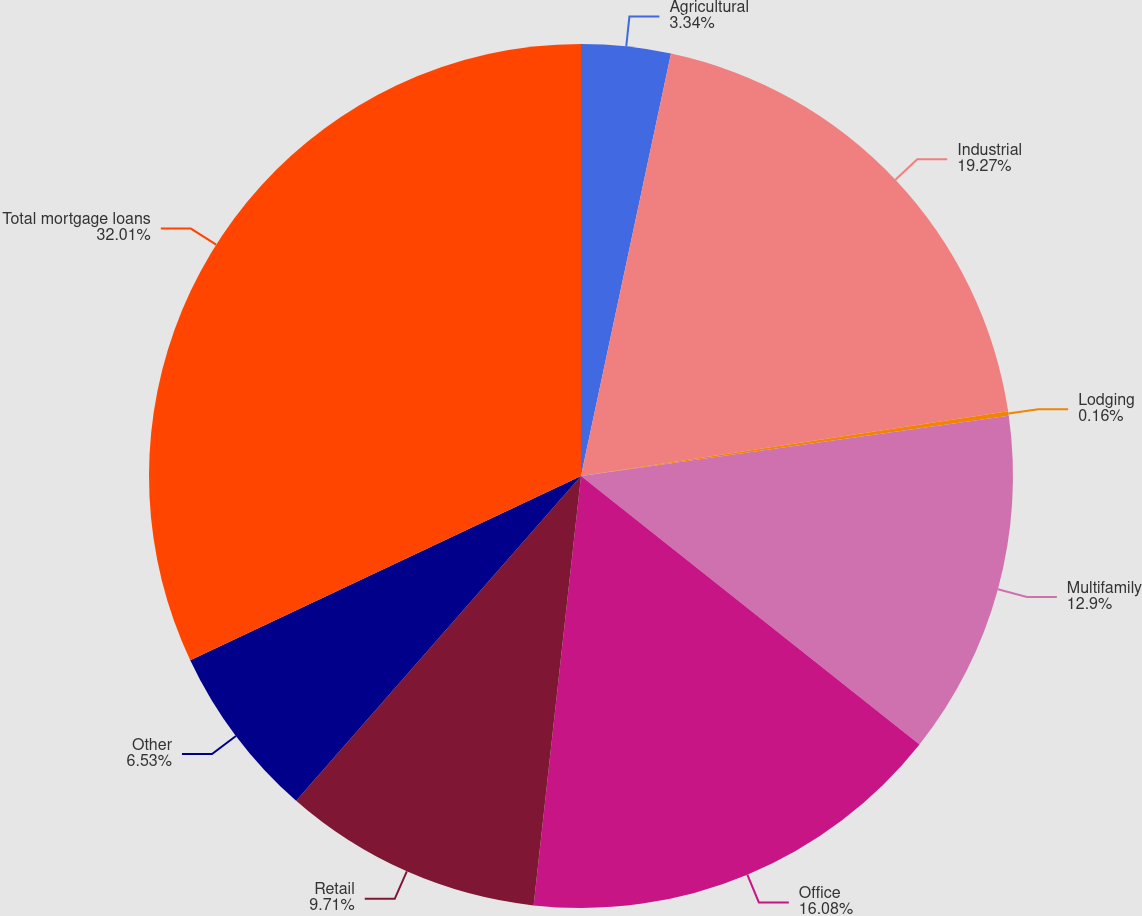Convert chart to OTSL. <chart><loc_0><loc_0><loc_500><loc_500><pie_chart><fcel>Agricultural<fcel>Industrial<fcel>Lodging<fcel>Multifamily<fcel>Office<fcel>Retail<fcel>Other<fcel>Total mortgage loans<nl><fcel>3.34%<fcel>19.27%<fcel>0.16%<fcel>12.9%<fcel>16.08%<fcel>9.71%<fcel>6.53%<fcel>32.01%<nl></chart> 